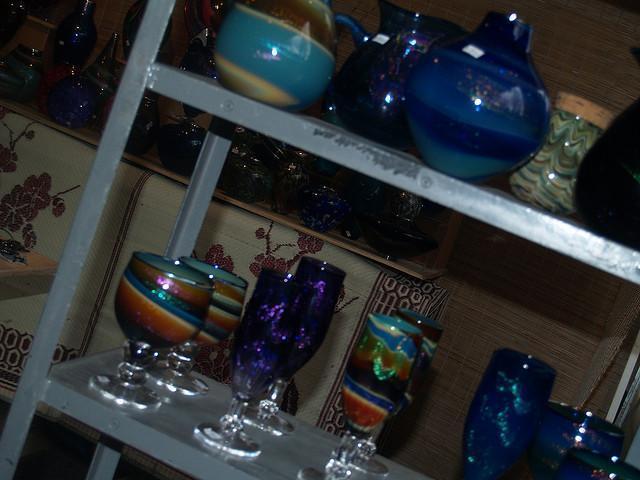How many wine glasses are visible?
Give a very brief answer. 9. How many vases are there?
Give a very brief answer. 7. How many pizzas are there?
Give a very brief answer. 0. 